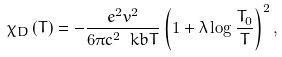Convert formula to latex. <formula><loc_0><loc_0><loc_500><loc_500>\chi _ { D } \left ( T \right ) = - \frac { e ^ { 2 } v ^ { 2 } } { 6 \pi c ^ { 2 } \ k b T } \left ( 1 + \lambda \log \frac { T _ { 0 } } { T } \right ) ^ { 2 } ,</formula> 